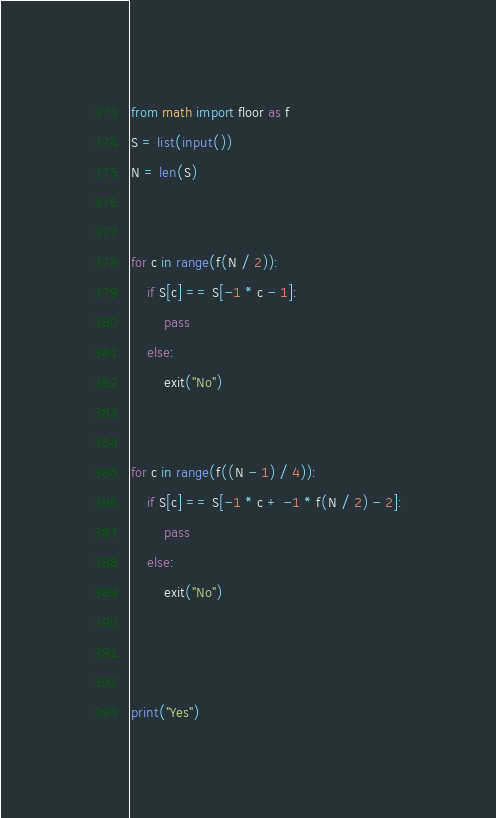<code> <loc_0><loc_0><loc_500><loc_500><_Python_>from math import floor as f
S = list(input())
N = len(S)


for c in range(f(N / 2)):
    if S[c] == S[-1 * c - 1]:
        pass
    else:
        exit("No")


for c in range(f((N - 1) / 4)):
    if S[c] == S[-1 * c + -1 * f(N / 2) - 2]:
        pass
    else:
        exit("No")



print("Yes")</code> 